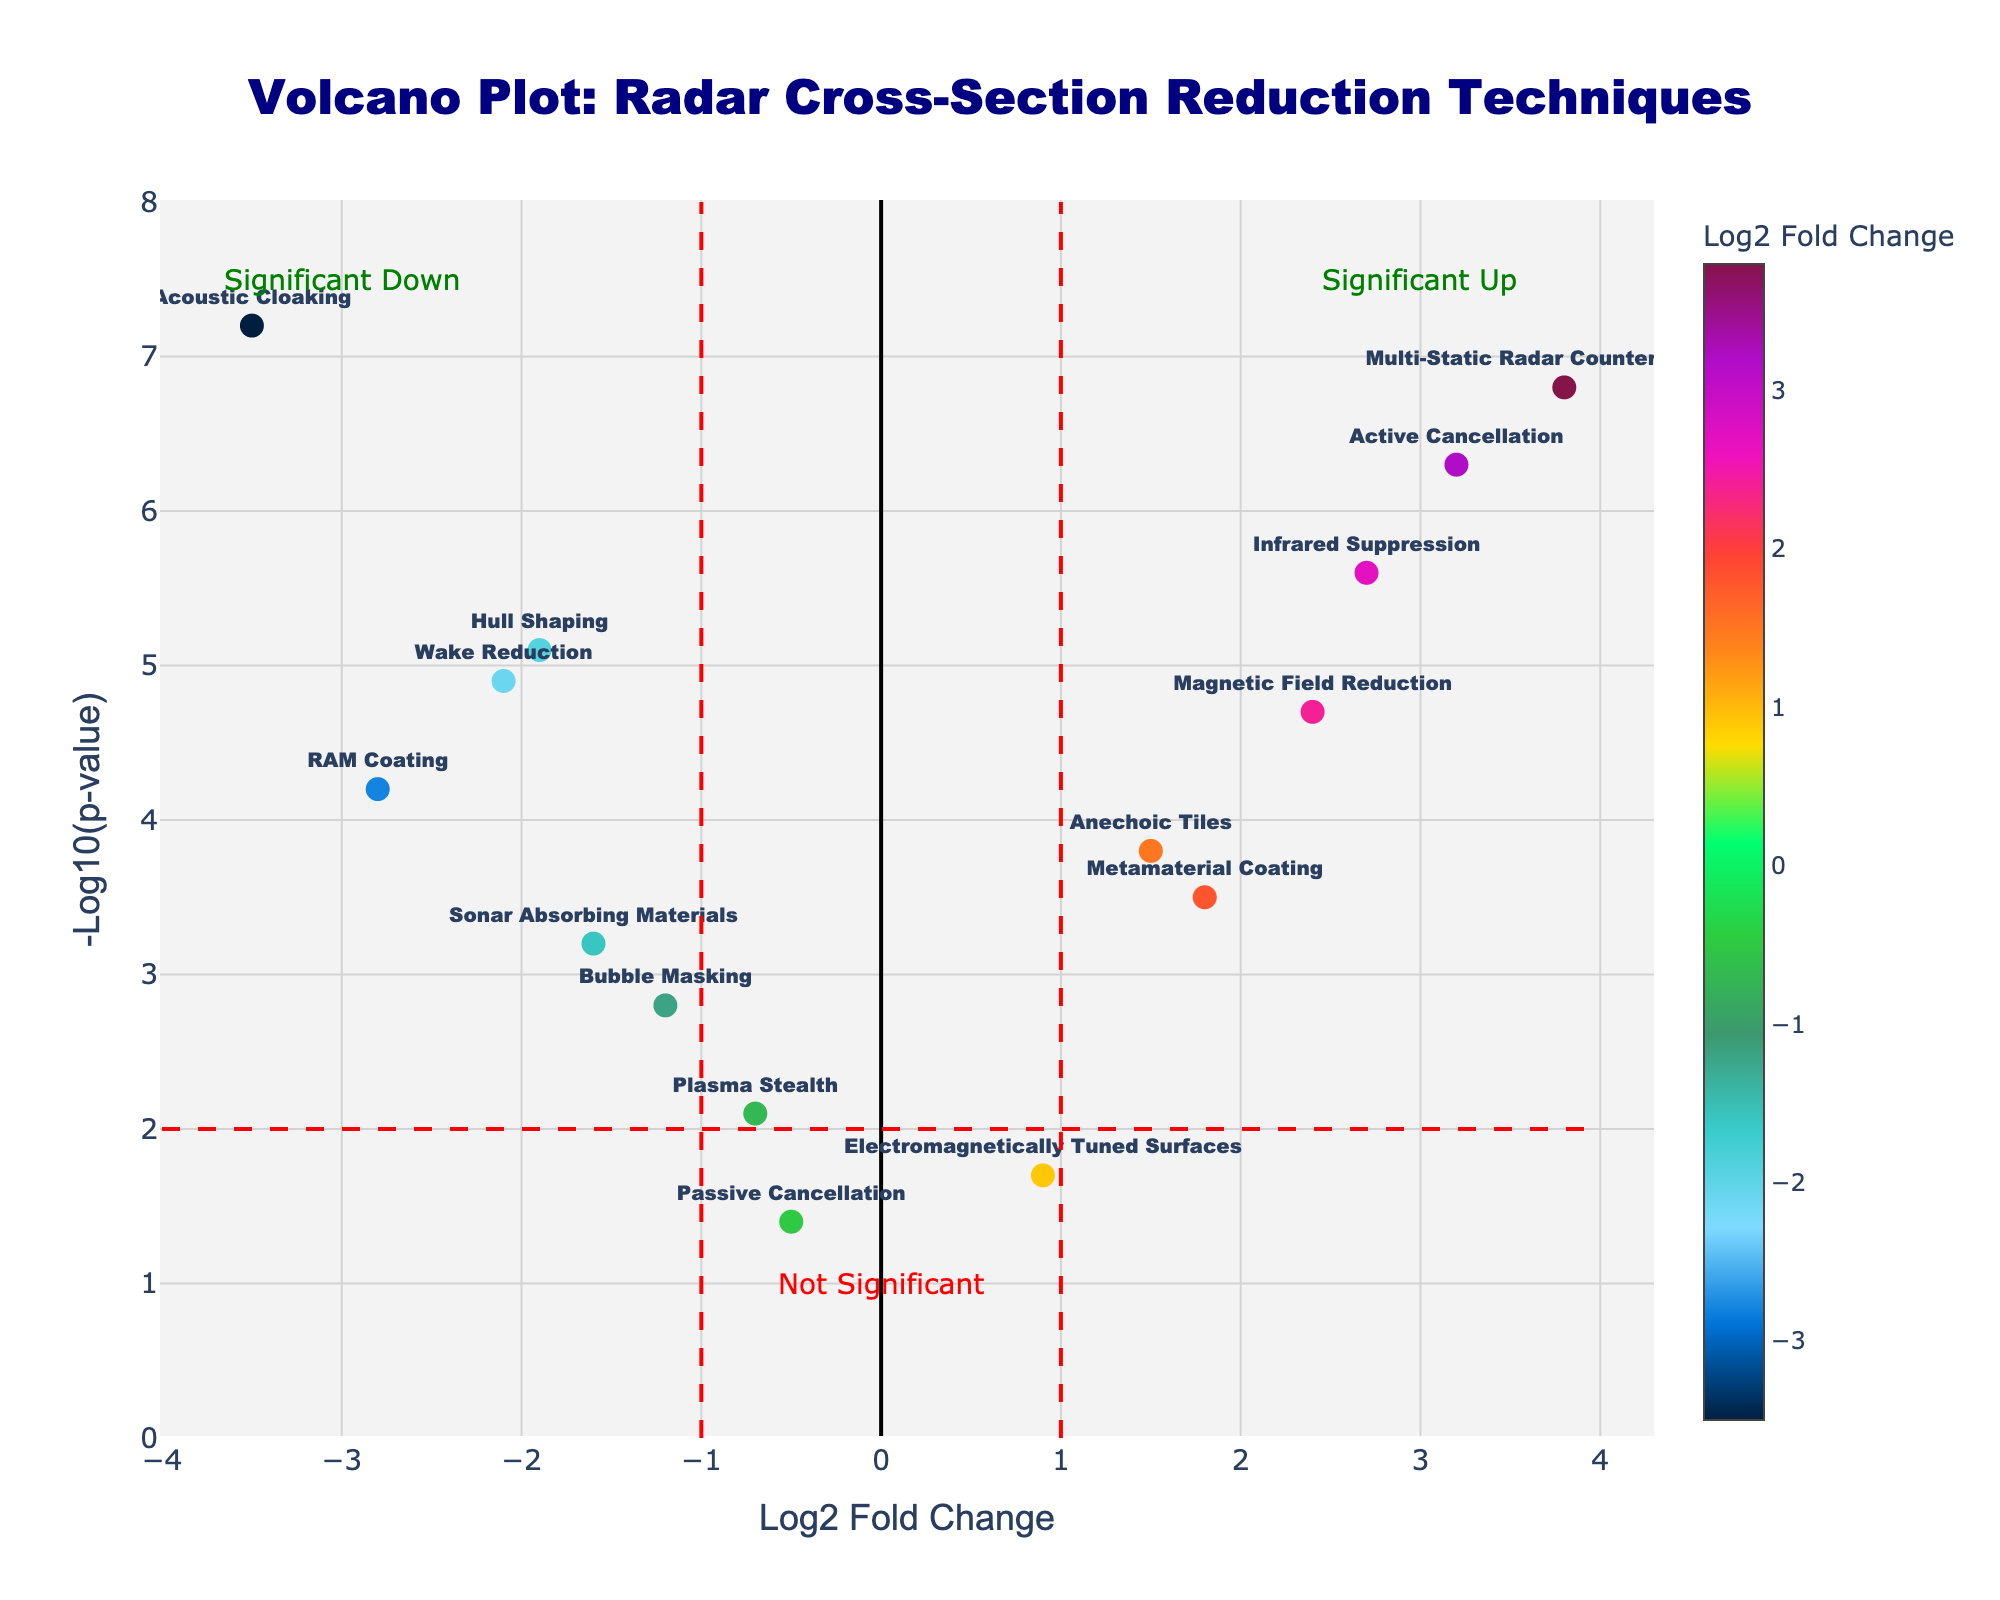Which technique has the highest log2 fold change? To determine the technique with the highest log2 fold change, look for the marker furthest to the right on the x-axis. Multi-Static Radar Countermeasures is at log2 fold change of 3.8.
Answer: Multi-Static Radar Countermeasures Which technique has the lowest -log10(p-value)? To find the technique with the lowest -log10(p-value), look for the data point closest to the x-axis. Electromagnetically Tuned Surfaces is at -log10(p-value) of 1.7.
Answer: Electromagnetically Tuned Surfaces How many techniques have a log2 fold change greater than 1? Identify the number of data points to the right of the vertical line at log2 fold change of 1. There are 6 techniques: Anechoic Tiles, Active Cancellation, Magnetic Field Reduction, Metamaterial Coating, Infrared Suppression, and Multi-Static Radar Countermeasures.
Answer: 6 Which technique is the most statistically significant with a negative log2 fold change? To find the most statistically significant technique with a negative log2 fold change, look for the data point with the highest -log10(p-value) on the left side of the plot. Acoustic Cloaking is at -log10(p-value) of 7.2.
Answer: Acoustic Cloaking What does the horizontal line represent in the volcano plot? The horizontal line in the volcano plot indicates the threshold for significance in terms of -log10(p-value). It is at -log10(p-value) of 2, meaning any point above this line is considered statistically significant.
Answer: Significance threshold Which two techniques have the closest log2 fold changes but different significance levels? Look for two data points with similar x-axis values but different y-axis values. Metamaterial Coating (log2FC 1.8) and Anechoic Tiles (log2FC 1.5) have close log2 fold changes but different -log10(p-values) at 3.5 and 3.8, respectively.
Answer: Metamaterial Coating and Anechoic Tiles How many techniques are significantly upregulated? Identify the number of data points in the area labeled "Significant Up" (top-right quadrant). There are 5 techniques: Active Cancellation, Magnetic Field Reduction, Infrared Suppression, Metamaterial Coating, and Multi-Static Radar Countermeasures.
Answer: 5 